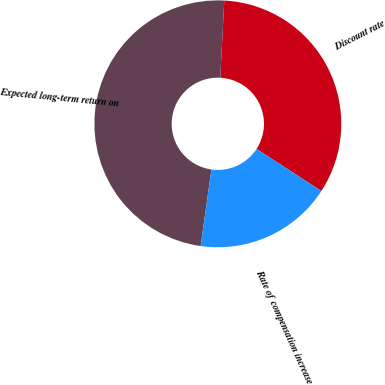Convert chart to OTSL. <chart><loc_0><loc_0><loc_500><loc_500><pie_chart><fcel>Discount rate<fcel>Expected long-term return on<fcel>Rate of compensation increase<nl><fcel>33.33%<fcel>48.61%<fcel>18.06%<nl></chart> 